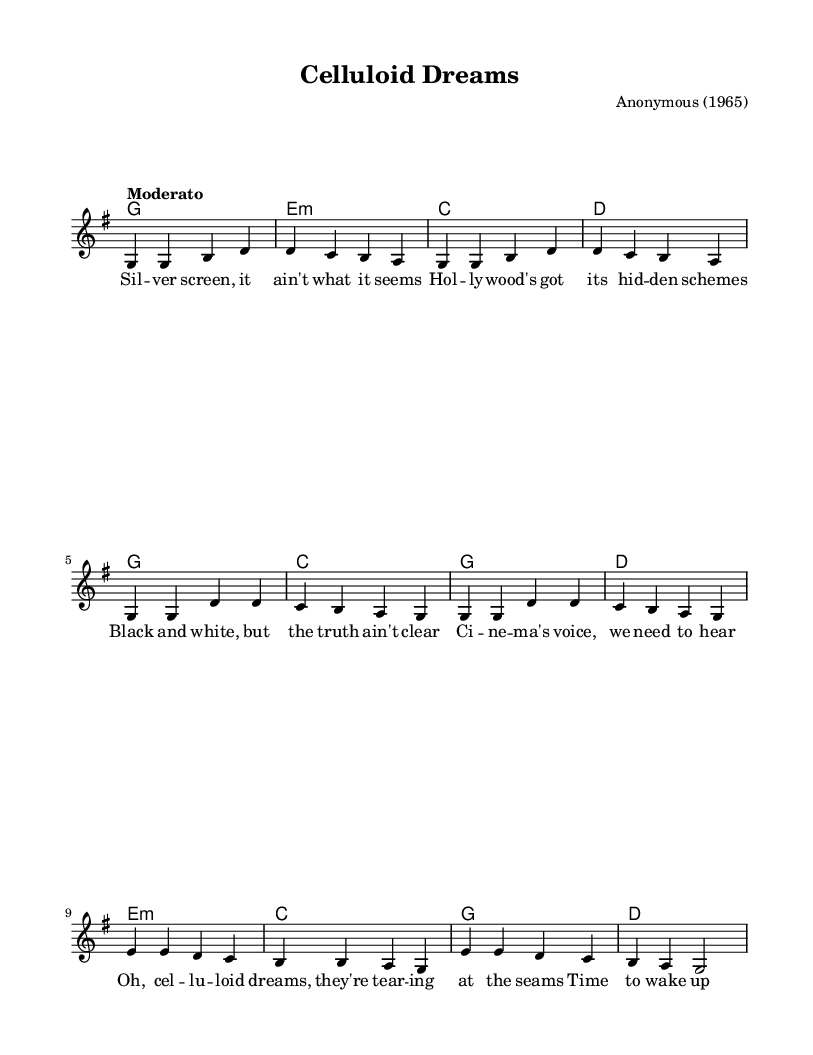What is the key signature of this music? The key signature shown at the beginning of the score indicates G major, which has one sharp (F#).
Answer: G major What is the time signature of this music? The time signature listed at the beginning of the score is 4/4, meaning there are four beats in each measure and the quarter note gets one beat.
Answer: 4/4 What is the tempo indicated for this piece? The tempo marking "Moderato" suggests a moderate speed, typically around 108 to 120 beats per minute.
Answer: Moderato How many sections does the song have? The song is divided into three distinct sections: the verse, the chorus, and the bridge. Each section has its own unique musical and lyrical content.
Answer: Three What is the defining lyrical theme of the song? The lyrics address the struggles and realities of cinema, emphasizing the need for truth in storytelling and reflecting social issues, typical of folk protest songs.
Answer: Social issues What chord follows the chorus in the first repetition? In the first repetition of the chorus, the chord progression starts with G major followed by D major in the next measure.
Answer: D major What function do the lyrics serve in this folk piece? The lyrics function as a narrative element that highlights social critique and personal reflection, common in folk music, particularly protest songs from the 1960s.
Answer: Narrative 